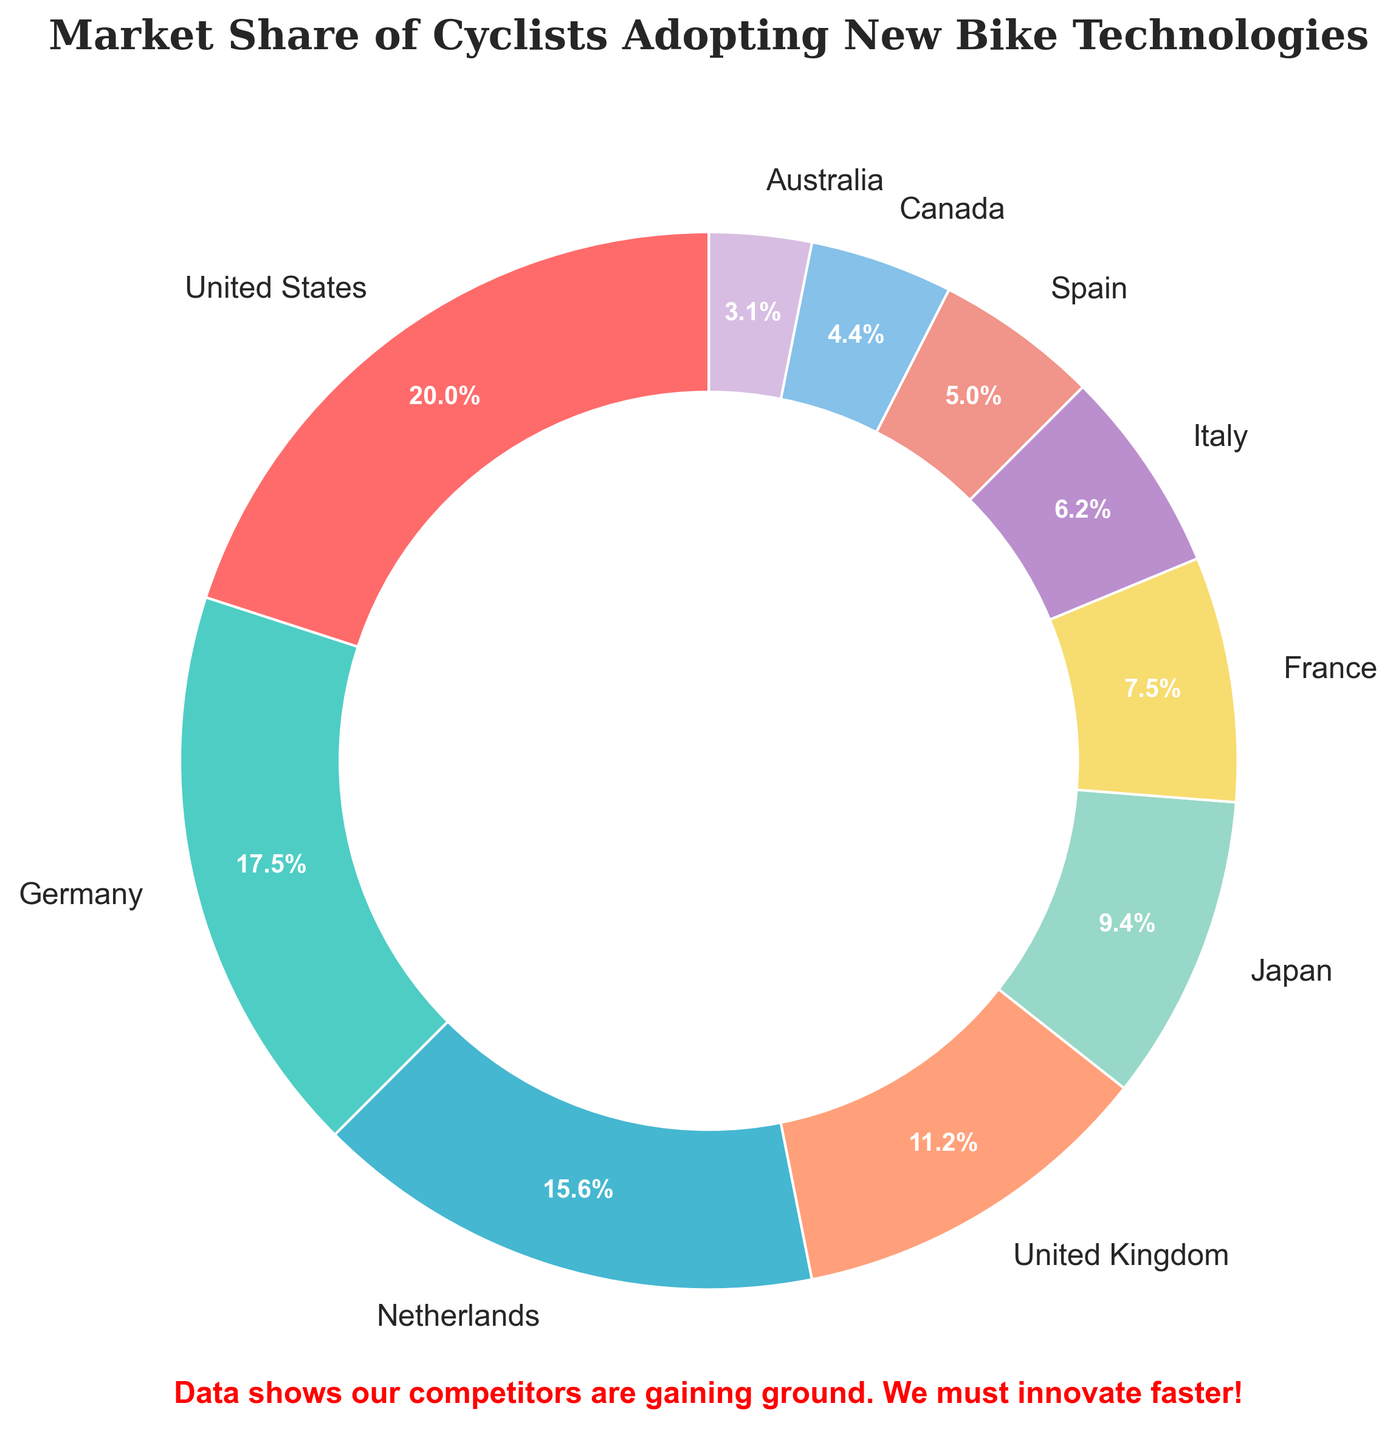Which market has the highest percentage of cyclists adopting new bike technologies? To find the answer, look at the figure and identify the largest wedge. It is labeled "United States" with 32%.
Answer: United States Which two markets have the combined percentage of 40%? Add up the percentages of each market until you find two that total 40%. Germany (28%) and Spain (8%) together make 36%, not 40%. United Kingdom (18%) and France (12%) together make 30%, not 40%. Italy (10%) and Spain (8%) together make 18%, not 40%. Germany (28%) and Japan (15%) together make 43%, not 40%. United Kingdom (18%) and Japan (15%) together make 33%, not 40%. Canada (7%) and Germany (28%) together make 35%, not 40%. Netherlands (25%) and the United Kingdom (18%) together make 43%, not 40%. Finally, United States (32%) and Australia (5%) together make 37%, not 40%. Meaning that no two markets sum up to exactly 40%.
Answer: None What is the percentage difference between the United States and Italy? Subtract Italy’s percentage from United States' percentage: 32% - 10% = 22%.
Answer: 22% Which market has a circular segment colored blue? Look at the color associated with each market in the figure. The Netherlands is shown in blue.
Answer: Netherlands Is the number of markets with percentage above 15% greater than the number of markets with percentage below 15%? Count the markets with percentages above 15%: United States (32%), Germany (28%), Netherlands (25%), United Kingdom (18%), and Japan (15%) make 5 markets. For below 15%: France (12%), Italy (10%), Spain (8%), Canada (7%), and Australia (5%) make 5 markets. Therefore, the numbers are equal.
Answer: No Which three markets together form just over 50% of the total percentage? Combine the percentages of markets until their sum exceeds 50%. The United States (32%), Germany (28%) equals 60%, which is over 50%. Adding the Netherlands (25%) would make it 85%, which is much more than half. Try combining United States (32%), United Kingdom (18%), and France (12%) - 32 + 18 + 12 = 62%, so it's still more than 50%. Therefore, United States, Germany and Netherlands together form just over 50%.
Answer: United States, Germany, Netherlands 